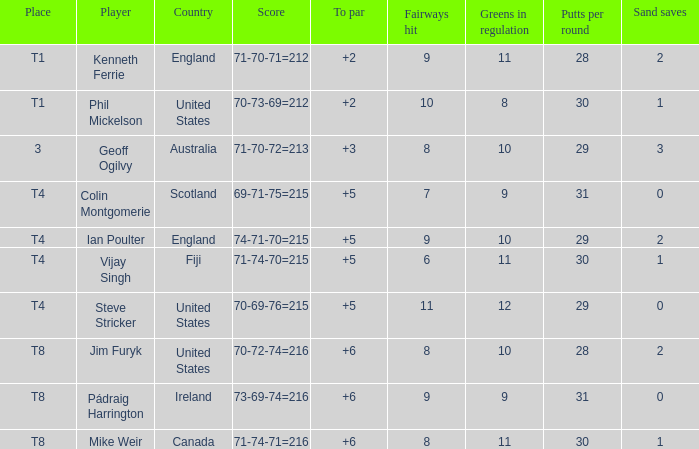What score to highest to par did Mike Weir achieve? 6.0. 